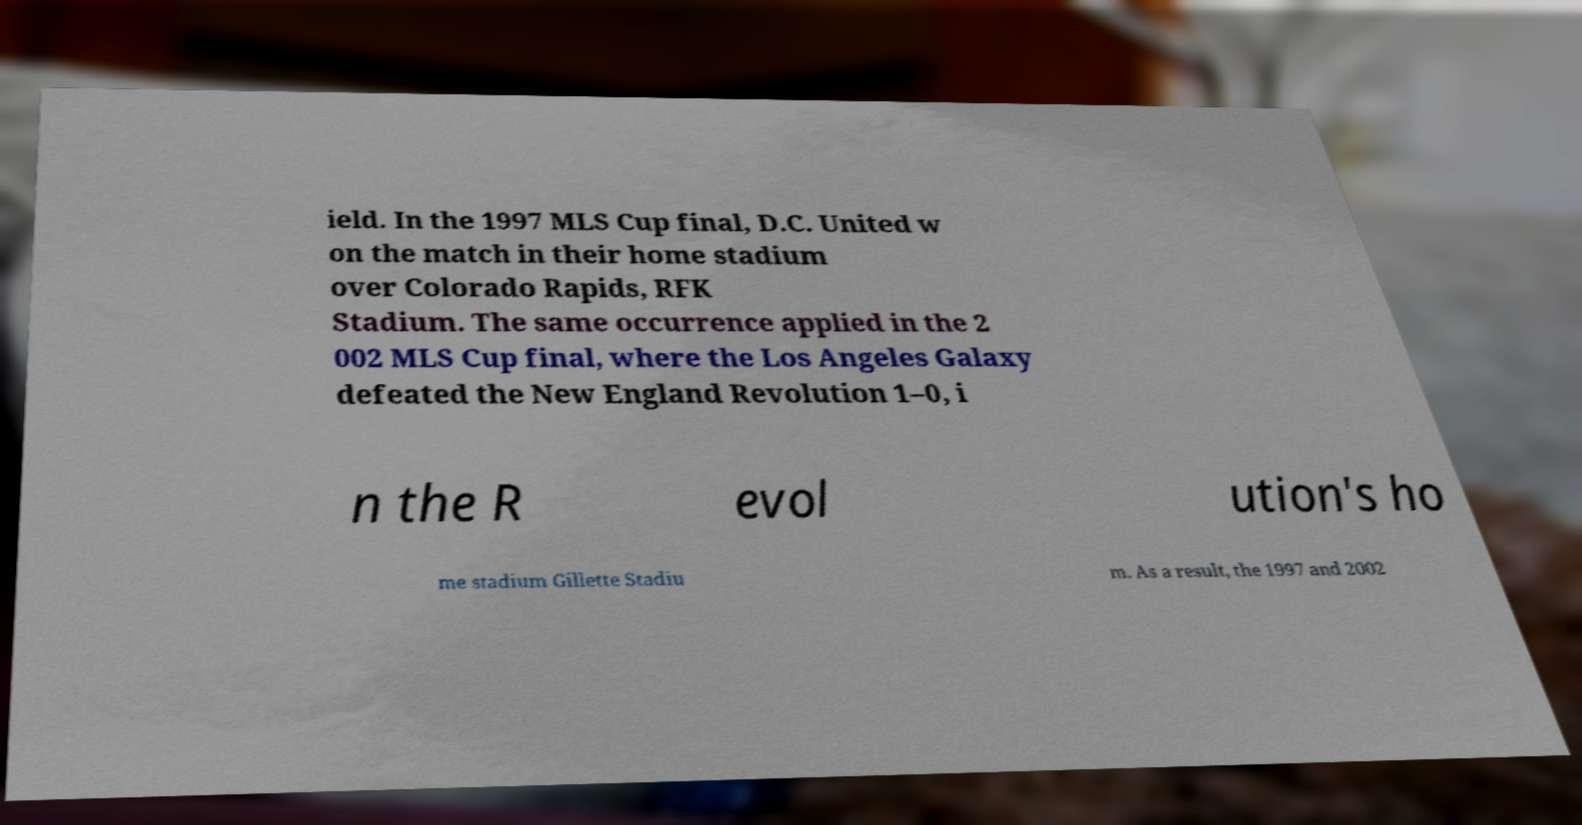What messages or text are displayed in this image? I need them in a readable, typed format. ield. In the 1997 MLS Cup final, D.C. United w on the match in their home stadium over Colorado Rapids, RFK Stadium. The same occurrence applied in the 2 002 MLS Cup final, where the Los Angeles Galaxy defeated the New England Revolution 1–0, i n the R evol ution's ho me stadium Gillette Stadiu m. As a result, the 1997 and 2002 